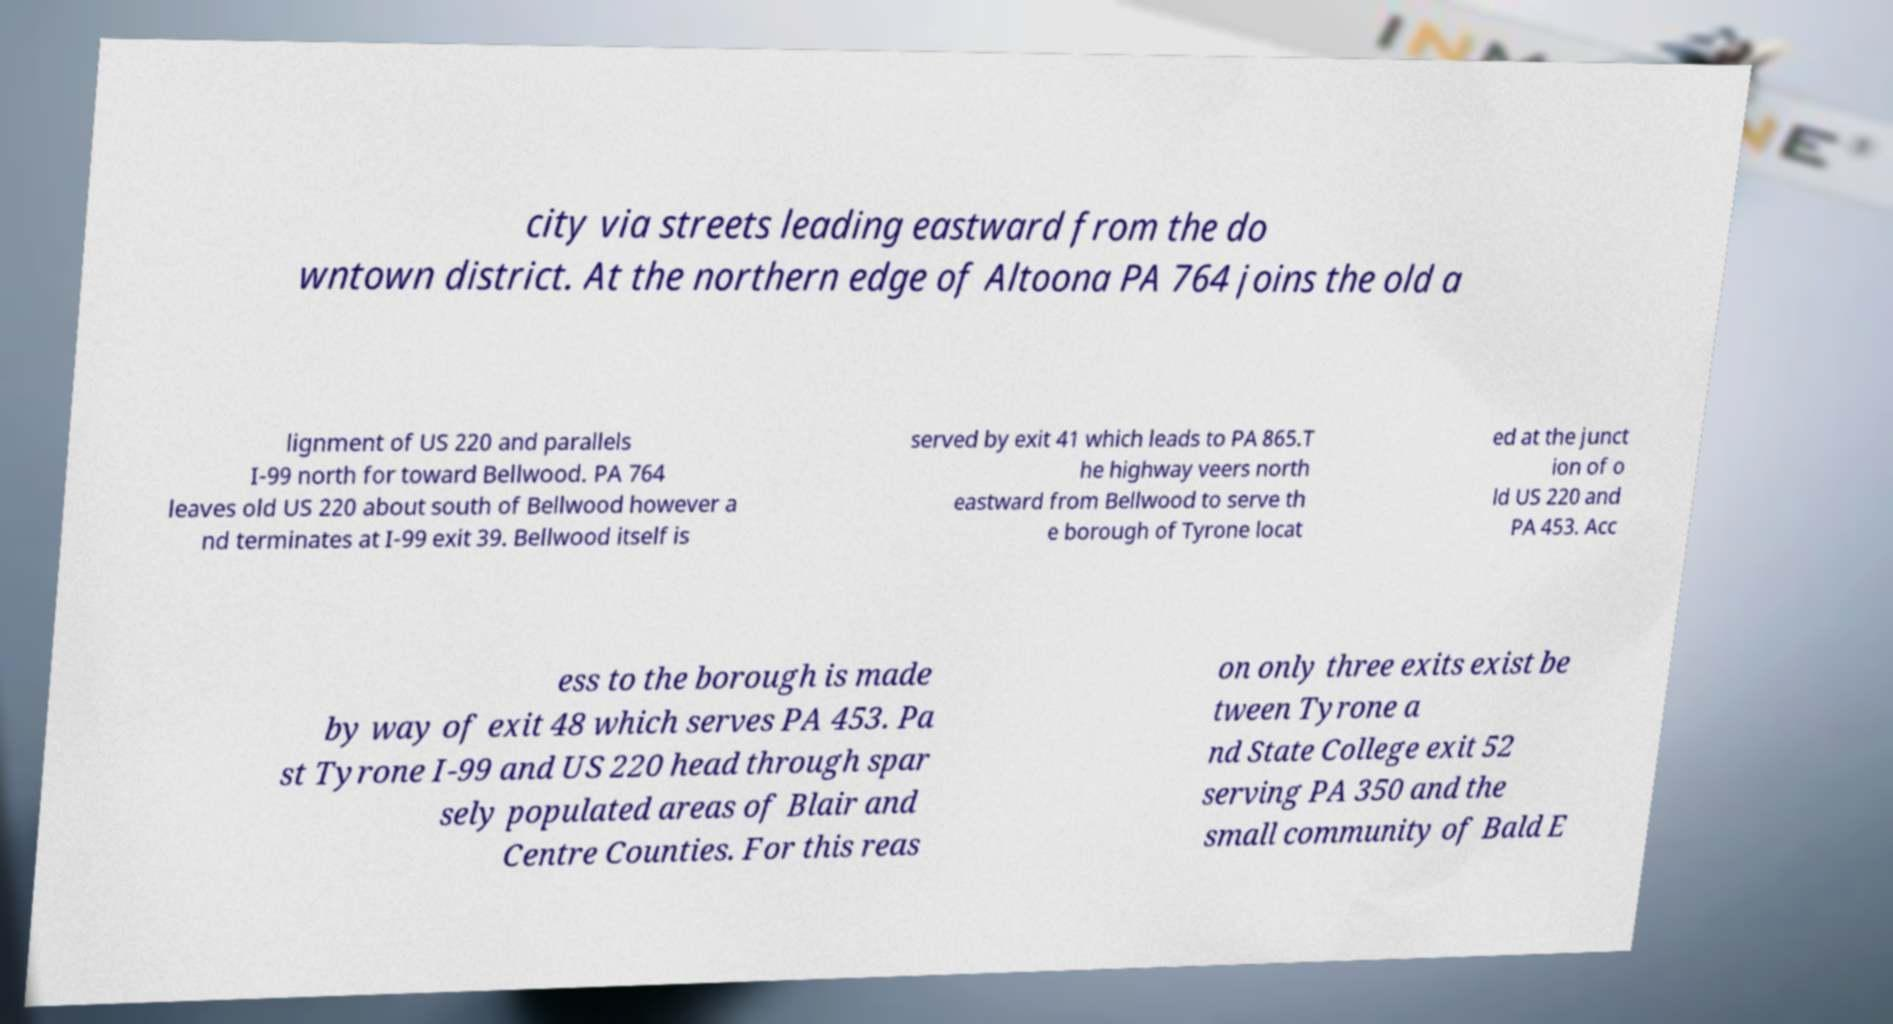I need the written content from this picture converted into text. Can you do that? city via streets leading eastward from the do wntown district. At the northern edge of Altoona PA 764 joins the old a lignment of US 220 and parallels I-99 north for toward Bellwood. PA 764 leaves old US 220 about south of Bellwood however a nd terminates at I-99 exit 39. Bellwood itself is served by exit 41 which leads to PA 865.T he highway veers north eastward from Bellwood to serve th e borough of Tyrone locat ed at the junct ion of o ld US 220 and PA 453. Acc ess to the borough is made by way of exit 48 which serves PA 453. Pa st Tyrone I-99 and US 220 head through spar sely populated areas of Blair and Centre Counties. For this reas on only three exits exist be tween Tyrone a nd State College exit 52 serving PA 350 and the small community of Bald E 